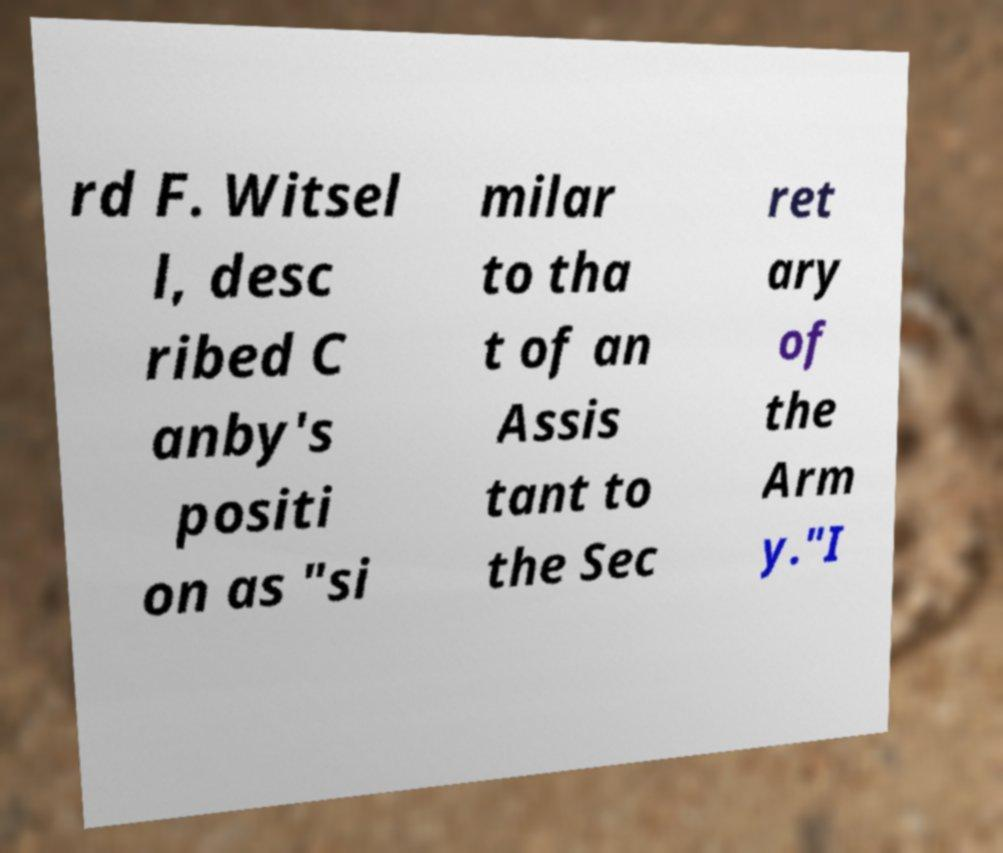What messages or text are displayed in this image? I need them in a readable, typed format. rd F. Witsel l, desc ribed C anby's positi on as "si milar to tha t of an Assis tant to the Sec ret ary of the Arm y."I 